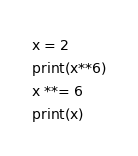Convert code to text. <code><loc_0><loc_0><loc_500><loc_500><_Python_>x = 2
print(x**6)
x **= 6
print(x)</code> 